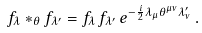<formula> <loc_0><loc_0><loc_500><loc_500>f _ { \lambda } * _ { \theta } f _ { \lambda ^ { \prime } } = f _ { \lambda } \, f _ { \lambda ^ { \prime } } \, e ^ { - \frac { i } { 2 } \lambda _ { \mu } \theta ^ { \mu \nu } \lambda ^ { \prime } _ { \nu } } \, .</formula> 